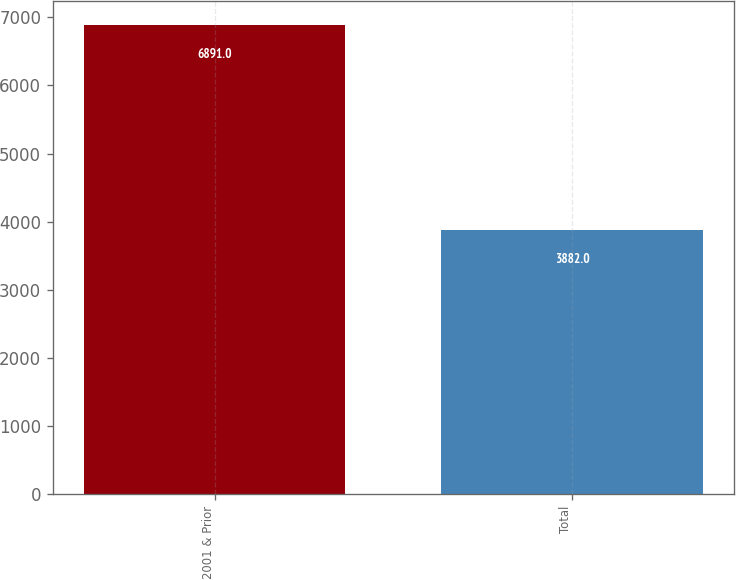Convert chart. <chart><loc_0><loc_0><loc_500><loc_500><bar_chart><fcel>2001 & Prior<fcel>Total<nl><fcel>6891<fcel>3882<nl></chart> 